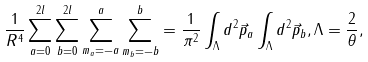<formula> <loc_0><loc_0><loc_500><loc_500>\frac { 1 } { R ^ { 4 } } \sum _ { a = 0 } ^ { 2 l } \sum _ { b = 0 } ^ { 2 l } \sum _ { m _ { a } = - a } ^ { a } \sum _ { m _ { b } = - b } ^ { b } = \frac { 1 } { \pi ^ { 2 } } \int _ { \Lambda } d ^ { 2 } \vec { p } _ { a } \int _ { \Lambda } d ^ { 2 } \vec { p } _ { b } , \Lambda = \frac { 2 } { \theta } ,</formula> 